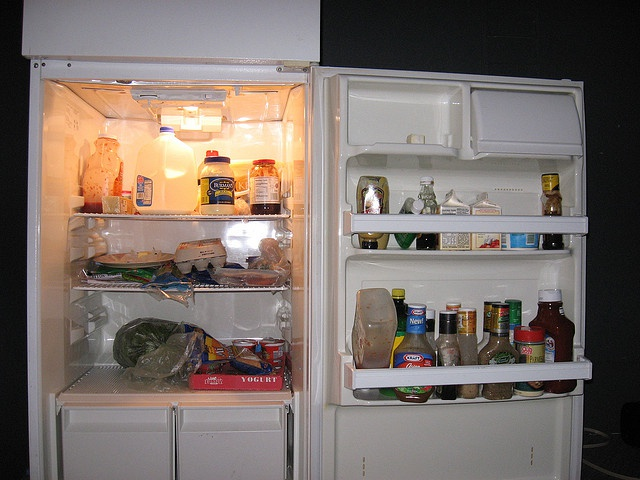Describe the objects in this image and their specific colors. I can see refrigerator in darkgray, black, and gray tones, bottle in black, gray, darkgray, and olive tones, bottle in black, darkgray, and gray tones, bottle in black, darkgray, and gray tones, and bottle in black, gray, maroon, and darkgreen tones in this image. 